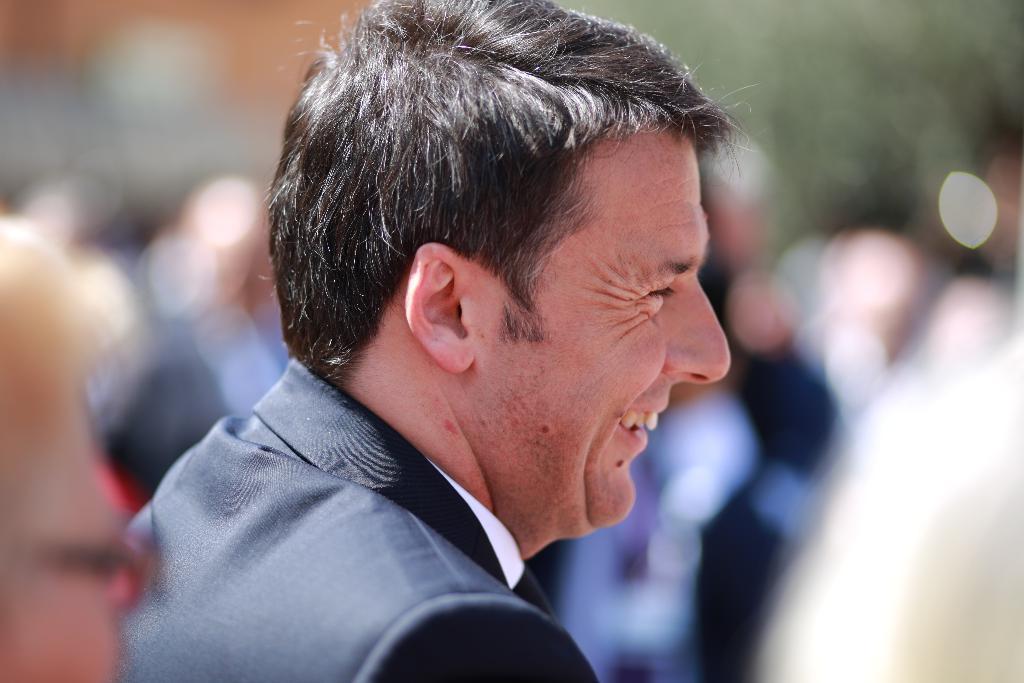Describe this image in one or two sentences. In the middle of the image we can see a man is smiling. Around that man it is blurry. 